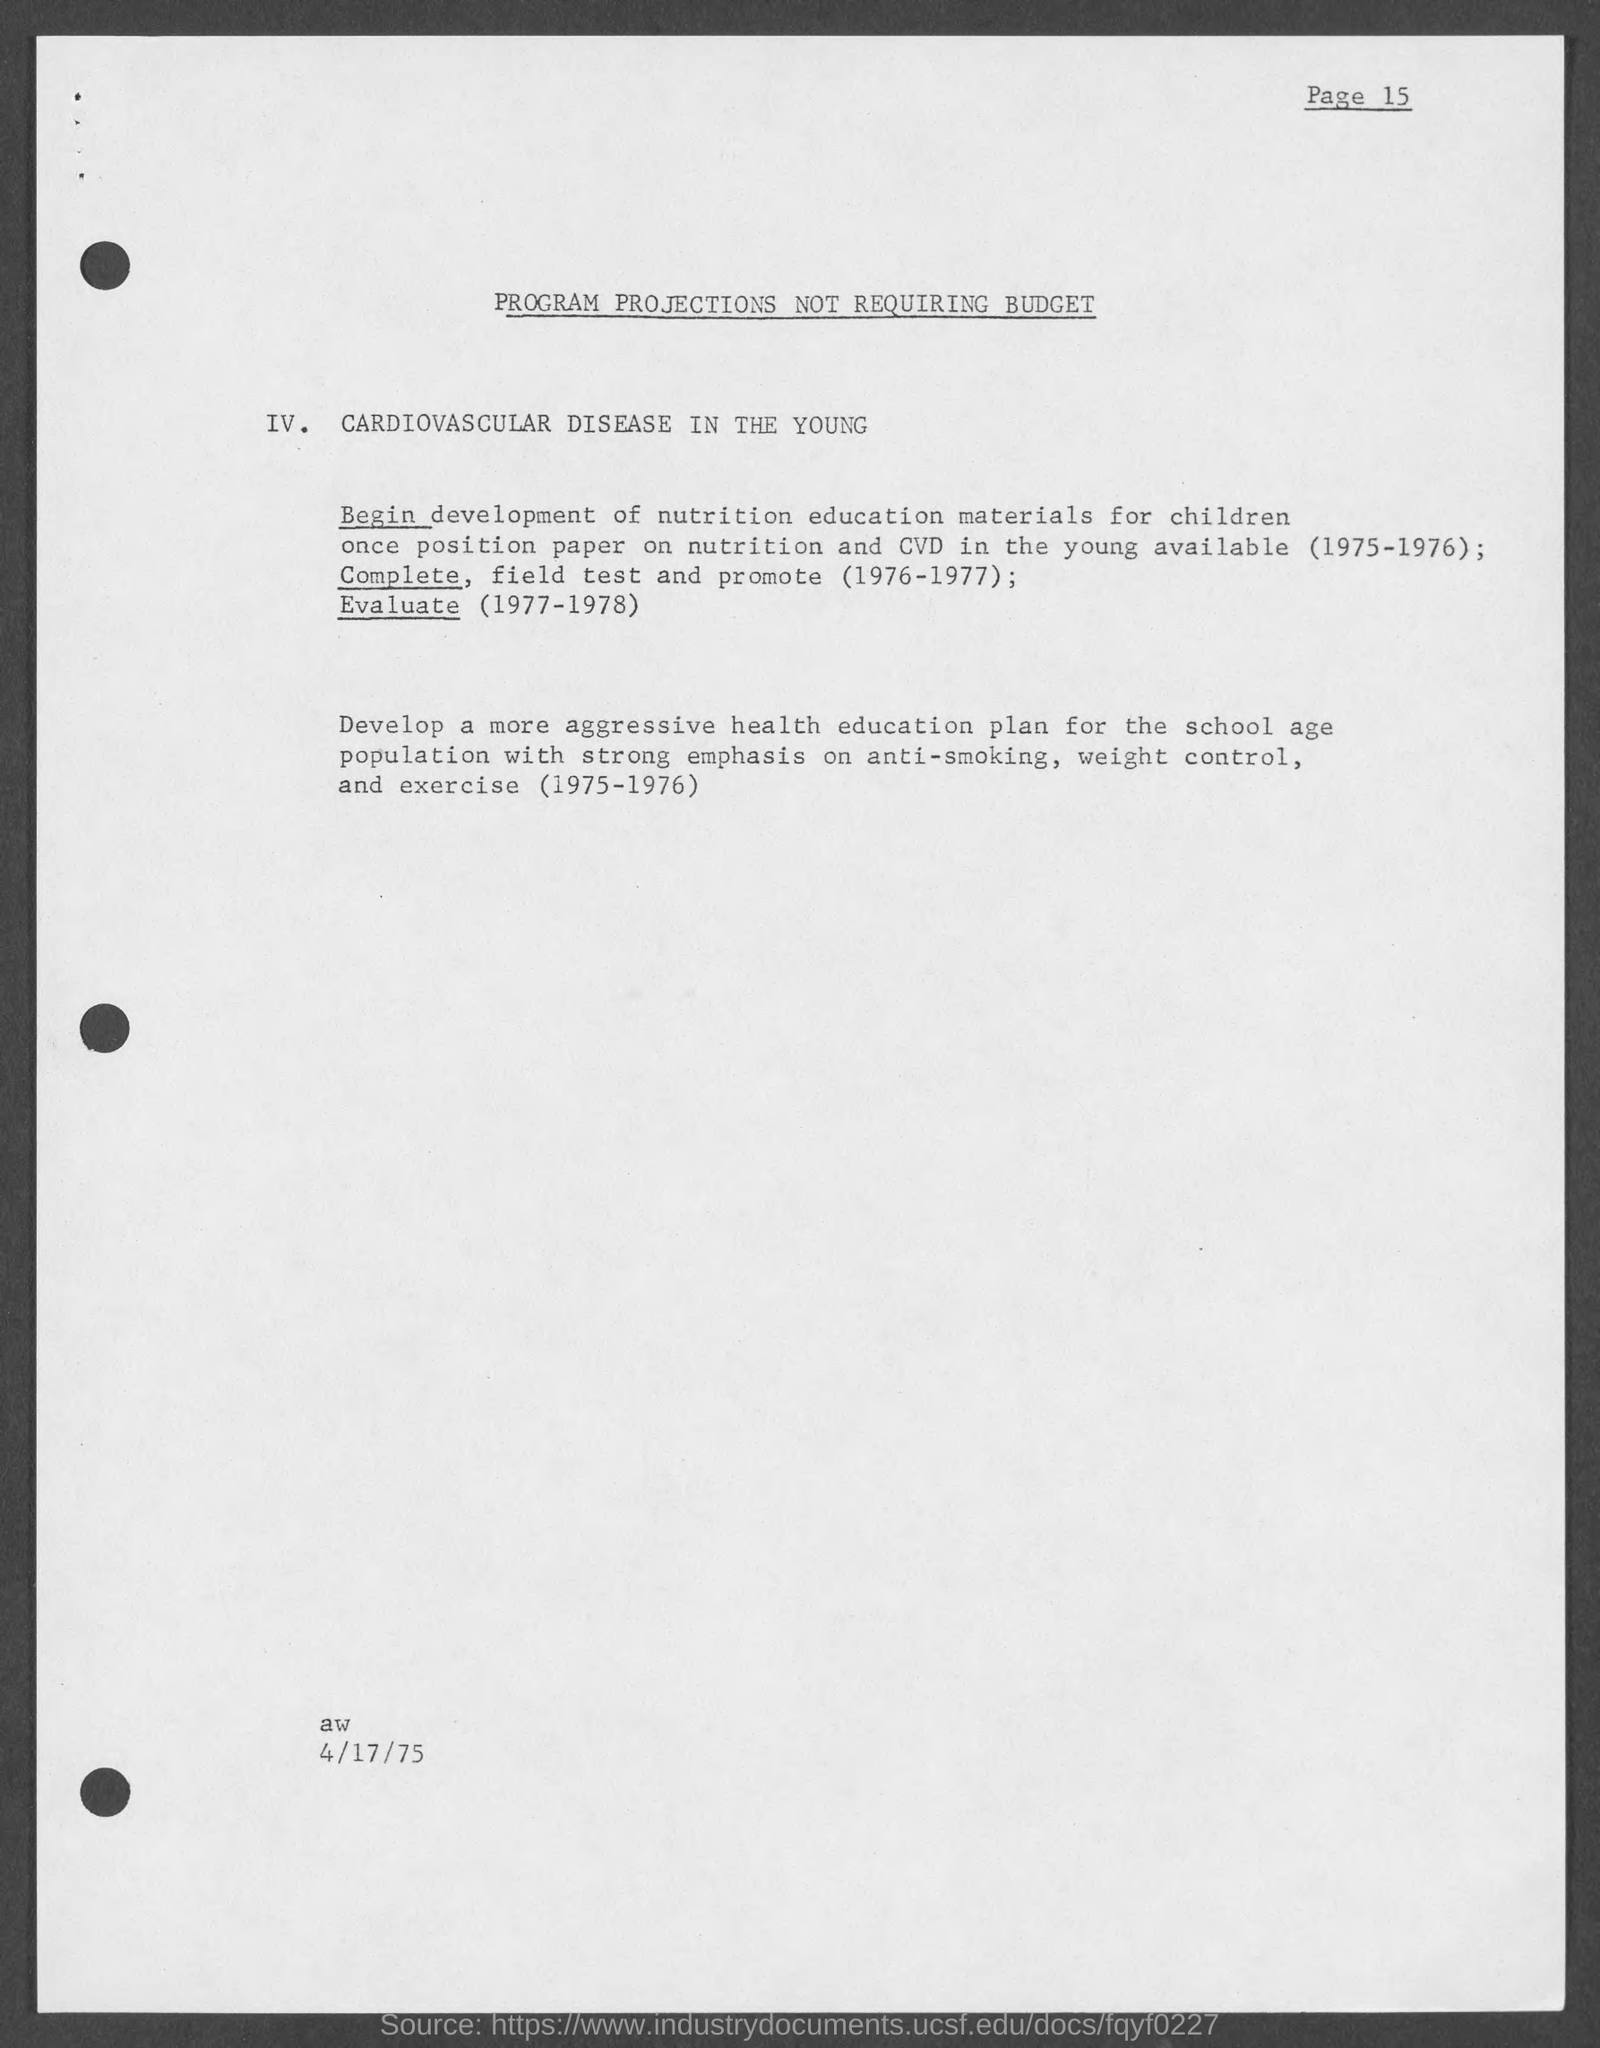Indicate a few pertinent items in this graphic. The instruction provided to school-age children in this program is focused on anti-smoking, weight control, and exercise. 